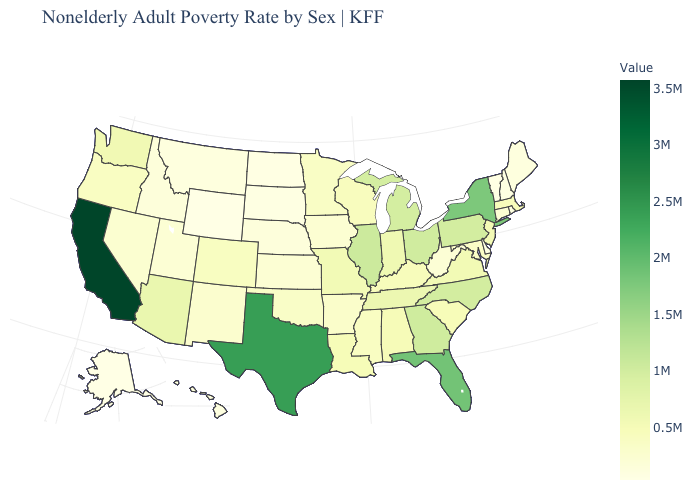Does New York have the highest value in the Northeast?
Keep it brief. Yes. Which states hav the highest value in the Northeast?
Short answer required. New York. Among the states that border West Virginia , does Pennsylvania have the highest value?
Keep it brief. No. Among the states that border Minnesota , which have the lowest value?
Quick response, please. North Dakota. 